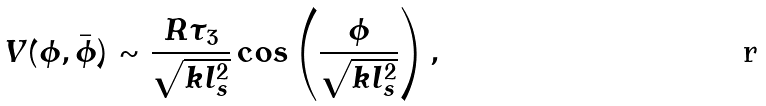Convert formula to latex. <formula><loc_0><loc_0><loc_500><loc_500>V ( \phi , \bar { \phi } ) \sim \frac { R \tau _ { 3 } } { \sqrt { k l _ { s } ^ { 2 } } } \cos \left ( \frac { \phi } { \sqrt { k l _ { s } ^ { 2 } } } \right ) ,</formula> 